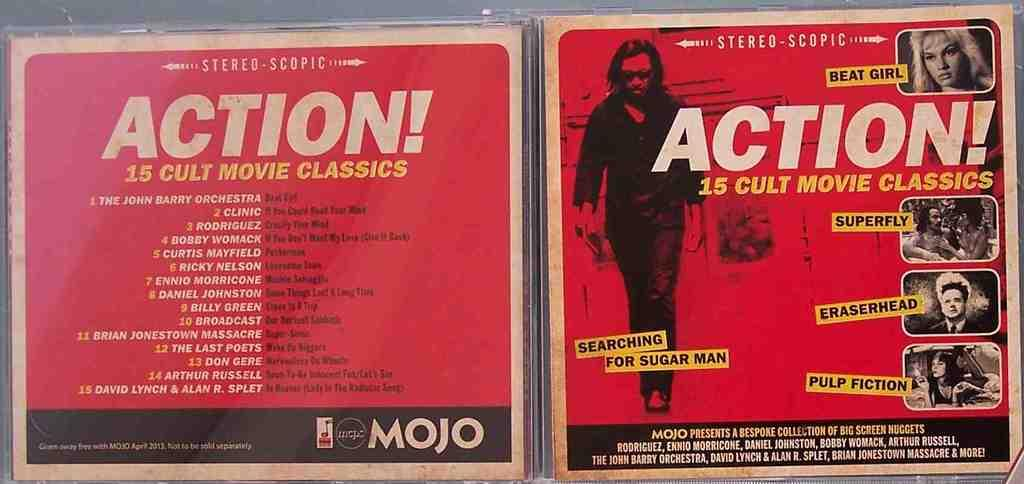Provide a one-sentence caption for the provided image. The front and back cover art for compilation album ACTION! 15 CULT MOVIE CLASSICS. 